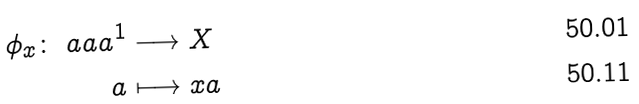Convert formula to latex. <formula><loc_0><loc_0><loc_500><loc_500>\phi _ { x } \colon \ a a a ^ { 1 } & \longrightarrow X \\ a & \longmapsto x a</formula> 